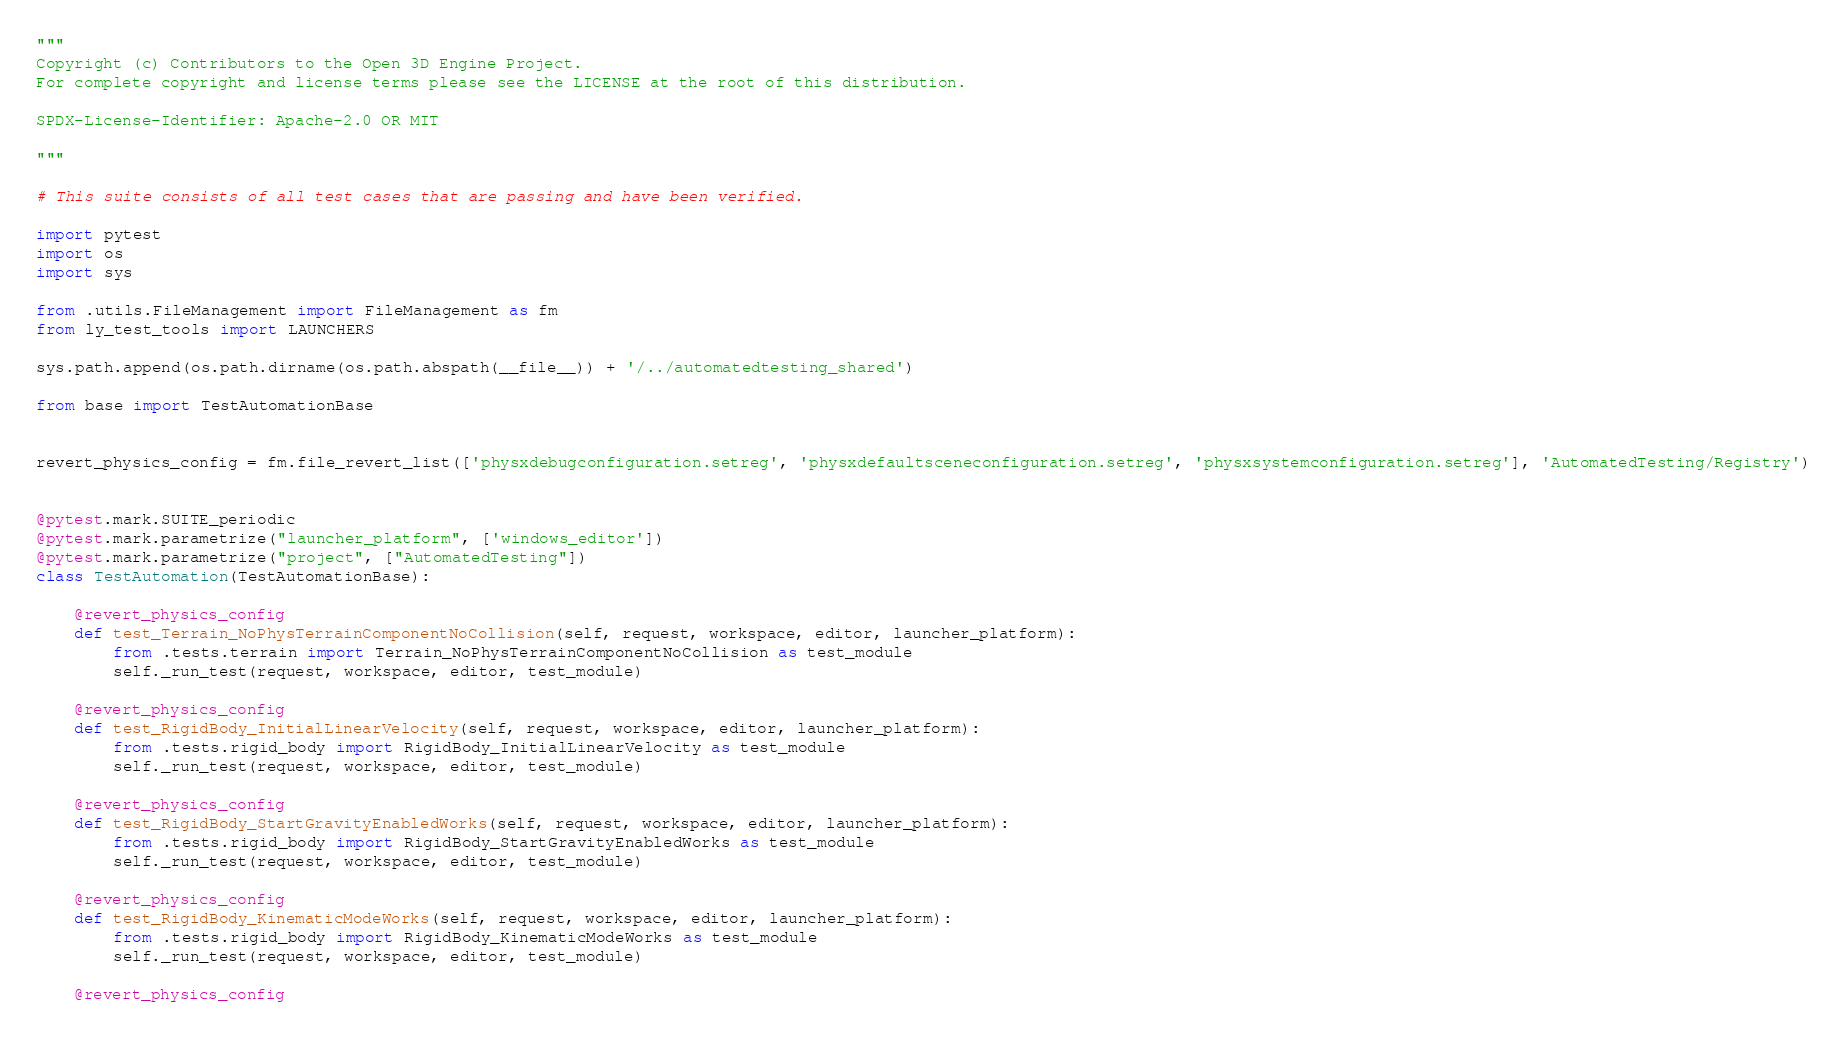Convert code to text. <code><loc_0><loc_0><loc_500><loc_500><_Python_>"""
Copyright (c) Contributors to the Open 3D Engine Project.
For complete copyright and license terms please see the LICENSE at the root of this distribution.

SPDX-License-Identifier: Apache-2.0 OR MIT

"""

# This suite consists of all test cases that are passing and have been verified.

import pytest
import os
import sys

from .utils.FileManagement import FileManagement as fm
from ly_test_tools import LAUNCHERS

sys.path.append(os.path.dirname(os.path.abspath(__file__)) + '/../automatedtesting_shared')

from base import TestAutomationBase


revert_physics_config = fm.file_revert_list(['physxdebugconfiguration.setreg', 'physxdefaultsceneconfiguration.setreg', 'physxsystemconfiguration.setreg'], 'AutomatedTesting/Registry')


@pytest.mark.SUITE_periodic
@pytest.mark.parametrize("launcher_platform", ['windows_editor'])
@pytest.mark.parametrize("project", ["AutomatedTesting"])
class TestAutomation(TestAutomationBase):

    @revert_physics_config
    def test_Terrain_NoPhysTerrainComponentNoCollision(self, request, workspace, editor, launcher_platform):
        from .tests.terrain import Terrain_NoPhysTerrainComponentNoCollision as test_module
        self._run_test(request, workspace, editor, test_module)
        
    @revert_physics_config
    def test_RigidBody_InitialLinearVelocity(self, request, workspace, editor, launcher_platform):
        from .tests.rigid_body import RigidBody_InitialLinearVelocity as test_module
        self._run_test(request, workspace, editor, test_module)

    @revert_physics_config
    def test_RigidBody_StartGravityEnabledWorks(self, request, workspace, editor, launcher_platform):
        from .tests.rigid_body import RigidBody_StartGravityEnabledWorks as test_module
        self._run_test(request, workspace, editor, test_module)

    @revert_physics_config
    def test_RigidBody_KinematicModeWorks(self, request, workspace, editor, launcher_platform):
        from .tests.rigid_body import RigidBody_KinematicModeWorks as test_module
        self._run_test(request, workspace, editor, test_module)

    @revert_physics_config</code> 